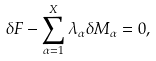Convert formula to latex. <formula><loc_0><loc_0><loc_500><loc_500>\delta F - \sum _ { \alpha = 1 } ^ { X } \lambda _ { \alpha } \delta M _ { \alpha } = 0 ,</formula> 